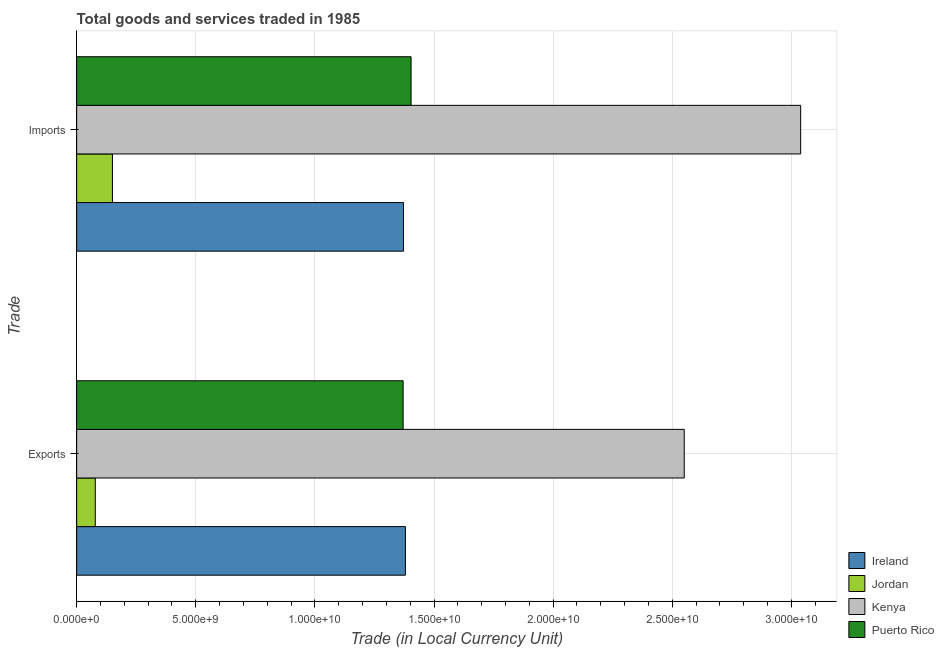Are the number of bars on each tick of the Y-axis equal?
Ensure brevity in your answer.  Yes. How many bars are there on the 2nd tick from the bottom?
Provide a short and direct response. 4. What is the label of the 2nd group of bars from the top?
Ensure brevity in your answer.  Exports. What is the export of goods and services in Ireland?
Your answer should be very brief. 1.38e+1. Across all countries, what is the maximum export of goods and services?
Give a very brief answer. 2.55e+1. Across all countries, what is the minimum imports of goods and services?
Provide a succinct answer. 1.50e+09. In which country was the imports of goods and services maximum?
Your answer should be very brief. Kenya. In which country was the export of goods and services minimum?
Your answer should be very brief. Jordan. What is the total export of goods and services in the graph?
Offer a very short reply. 5.38e+1. What is the difference between the export of goods and services in Jordan and that in Ireland?
Provide a succinct answer. -1.30e+1. What is the difference between the imports of goods and services in Ireland and the export of goods and services in Kenya?
Provide a succinct answer. -1.18e+1. What is the average export of goods and services per country?
Provide a succinct answer. 1.34e+1. What is the difference between the export of goods and services and imports of goods and services in Puerto Rico?
Make the answer very short. -3.34e+08. In how many countries, is the export of goods and services greater than 24000000000 LCU?
Your answer should be very brief. 1. What is the ratio of the imports of goods and services in Puerto Rico to that in Ireland?
Keep it short and to the point. 1.02. What does the 4th bar from the top in Imports represents?
Offer a very short reply. Ireland. What does the 1st bar from the bottom in Imports represents?
Your answer should be compact. Ireland. Are all the bars in the graph horizontal?
Your answer should be very brief. Yes. How many countries are there in the graph?
Offer a terse response. 4. What is the difference between two consecutive major ticks on the X-axis?
Offer a terse response. 5.00e+09. Does the graph contain grids?
Provide a short and direct response. Yes. How are the legend labels stacked?
Your answer should be compact. Vertical. What is the title of the graph?
Your answer should be very brief. Total goods and services traded in 1985. What is the label or title of the X-axis?
Provide a short and direct response. Trade (in Local Currency Unit). What is the label or title of the Y-axis?
Ensure brevity in your answer.  Trade. What is the Trade (in Local Currency Unit) in Ireland in Exports?
Keep it short and to the point. 1.38e+1. What is the Trade (in Local Currency Unit) in Jordan in Exports?
Keep it short and to the point. 7.82e+08. What is the Trade (in Local Currency Unit) of Kenya in Exports?
Your answer should be compact. 2.55e+1. What is the Trade (in Local Currency Unit) in Puerto Rico in Exports?
Ensure brevity in your answer.  1.37e+1. What is the Trade (in Local Currency Unit) of Ireland in Imports?
Provide a succinct answer. 1.37e+1. What is the Trade (in Local Currency Unit) of Jordan in Imports?
Make the answer very short. 1.50e+09. What is the Trade (in Local Currency Unit) in Kenya in Imports?
Offer a very short reply. 3.04e+1. What is the Trade (in Local Currency Unit) in Puerto Rico in Imports?
Keep it short and to the point. 1.40e+1. Across all Trade, what is the maximum Trade (in Local Currency Unit) of Ireland?
Offer a terse response. 1.38e+1. Across all Trade, what is the maximum Trade (in Local Currency Unit) of Jordan?
Provide a succinct answer. 1.50e+09. Across all Trade, what is the maximum Trade (in Local Currency Unit) in Kenya?
Keep it short and to the point. 3.04e+1. Across all Trade, what is the maximum Trade (in Local Currency Unit) of Puerto Rico?
Your response must be concise. 1.40e+1. Across all Trade, what is the minimum Trade (in Local Currency Unit) in Ireland?
Ensure brevity in your answer.  1.37e+1. Across all Trade, what is the minimum Trade (in Local Currency Unit) of Jordan?
Ensure brevity in your answer.  7.82e+08. Across all Trade, what is the minimum Trade (in Local Currency Unit) of Kenya?
Ensure brevity in your answer.  2.55e+1. Across all Trade, what is the minimum Trade (in Local Currency Unit) in Puerto Rico?
Make the answer very short. 1.37e+1. What is the total Trade (in Local Currency Unit) in Ireland in the graph?
Offer a terse response. 2.75e+1. What is the total Trade (in Local Currency Unit) of Jordan in the graph?
Provide a succinct answer. 2.28e+09. What is the total Trade (in Local Currency Unit) of Kenya in the graph?
Make the answer very short. 5.59e+1. What is the total Trade (in Local Currency Unit) in Puerto Rico in the graph?
Offer a terse response. 2.77e+1. What is the difference between the Trade (in Local Currency Unit) of Ireland in Exports and that in Imports?
Your response must be concise. 8.03e+07. What is the difference between the Trade (in Local Currency Unit) in Jordan in Exports and that in Imports?
Provide a short and direct response. -7.21e+08. What is the difference between the Trade (in Local Currency Unit) in Kenya in Exports and that in Imports?
Provide a short and direct response. -4.89e+09. What is the difference between the Trade (in Local Currency Unit) in Puerto Rico in Exports and that in Imports?
Offer a very short reply. -3.34e+08. What is the difference between the Trade (in Local Currency Unit) of Ireland in Exports and the Trade (in Local Currency Unit) of Jordan in Imports?
Offer a very short reply. 1.23e+1. What is the difference between the Trade (in Local Currency Unit) of Ireland in Exports and the Trade (in Local Currency Unit) of Kenya in Imports?
Offer a very short reply. -1.66e+1. What is the difference between the Trade (in Local Currency Unit) in Ireland in Exports and the Trade (in Local Currency Unit) in Puerto Rico in Imports?
Your answer should be compact. -2.37e+08. What is the difference between the Trade (in Local Currency Unit) of Jordan in Exports and the Trade (in Local Currency Unit) of Kenya in Imports?
Offer a very short reply. -2.96e+1. What is the difference between the Trade (in Local Currency Unit) of Jordan in Exports and the Trade (in Local Currency Unit) of Puerto Rico in Imports?
Provide a succinct answer. -1.33e+1. What is the difference between the Trade (in Local Currency Unit) of Kenya in Exports and the Trade (in Local Currency Unit) of Puerto Rico in Imports?
Provide a succinct answer. 1.15e+1. What is the average Trade (in Local Currency Unit) in Ireland per Trade?
Ensure brevity in your answer.  1.38e+1. What is the average Trade (in Local Currency Unit) of Jordan per Trade?
Ensure brevity in your answer.  1.14e+09. What is the average Trade (in Local Currency Unit) in Kenya per Trade?
Offer a terse response. 2.79e+1. What is the average Trade (in Local Currency Unit) in Puerto Rico per Trade?
Offer a very short reply. 1.39e+1. What is the difference between the Trade (in Local Currency Unit) of Ireland and Trade (in Local Currency Unit) of Jordan in Exports?
Ensure brevity in your answer.  1.30e+1. What is the difference between the Trade (in Local Currency Unit) in Ireland and Trade (in Local Currency Unit) in Kenya in Exports?
Make the answer very short. -1.17e+1. What is the difference between the Trade (in Local Currency Unit) of Ireland and Trade (in Local Currency Unit) of Puerto Rico in Exports?
Your response must be concise. 9.67e+07. What is the difference between the Trade (in Local Currency Unit) of Jordan and Trade (in Local Currency Unit) of Kenya in Exports?
Provide a short and direct response. -2.47e+1. What is the difference between the Trade (in Local Currency Unit) of Jordan and Trade (in Local Currency Unit) of Puerto Rico in Exports?
Give a very brief answer. -1.29e+1. What is the difference between the Trade (in Local Currency Unit) of Kenya and Trade (in Local Currency Unit) of Puerto Rico in Exports?
Provide a succinct answer. 1.18e+1. What is the difference between the Trade (in Local Currency Unit) of Ireland and Trade (in Local Currency Unit) of Jordan in Imports?
Provide a succinct answer. 1.22e+1. What is the difference between the Trade (in Local Currency Unit) of Ireland and Trade (in Local Currency Unit) of Kenya in Imports?
Provide a succinct answer. -1.67e+1. What is the difference between the Trade (in Local Currency Unit) in Ireland and Trade (in Local Currency Unit) in Puerto Rico in Imports?
Your answer should be very brief. -3.18e+08. What is the difference between the Trade (in Local Currency Unit) of Jordan and Trade (in Local Currency Unit) of Kenya in Imports?
Give a very brief answer. -2.89e+1. What is the difference between the Trade (in Local Currency Unit) of Jordan and Trade (in Local Currency Unit) of Puerto Rico in Imports?
Your answer should be very brief. -1.25e+1. What is the difference between the Trade (in Local Currency Unit) of Kenya and Trade (in Local Currency Unit) of Puerto Rico in Imports?
Your response must be concise. 1.64e+1. What is the ratio of the Trade (in Local Currency Unit) in Ireland in Exports to that in Imports?
Offer a very short reply. 1.01. What is the ratio of the Trade (in Local Currency Unit) of Jordan in Exports to that in Imports?
Your response must be concise. 0.52. What is the ratio of the Trade (in Local Currency Unit) of Kenya in Exports to that in Imports?
Make the answer very short. 0.84. What is the ratio of the Trade (in Local Currency Unit) of Puerto Rico in Exports to that in Imports?
Provide a short and direct response. 0.98. What is the difference between the highest and the second highest Trade (in Local Currency Unit) of Ireland?
Your answer should be compact. 8.03e+07. What is the difference between the highest and the second highest Trade (in Local Currency Unit) in Jordan?
Offer a terse response. 7.21e+08. What is the difference between the highest and the second highest Trade (in Local Currency Unit) of Kenya?
Make the answer very short. 4.89e+09. What is the difference between the highest and the second highest Trade (in Local Currency Unit) of Puerto Rico?
Ensure brevity in your answer.  3.34e+08. What is the difference between the highest and the lowest Trade (in Local Currency Unit) of Ireland?
Your answer should be compact. 8.03e+07. What is the difference between the highest and the lowest Trade (in Local Currency Unit) of Jordan?
Your response must be concise. 7.21e+08. What is the difference between the highest and the lowest Trade (in Local Currency Unit) in Kenya?
Offer a terse response. 4.89e+09. What is the difference between the highest and the lowest Trade (in Local Currency Unit) of Puerto Rico?
Keep it short and to the point. 3.34e+08. 